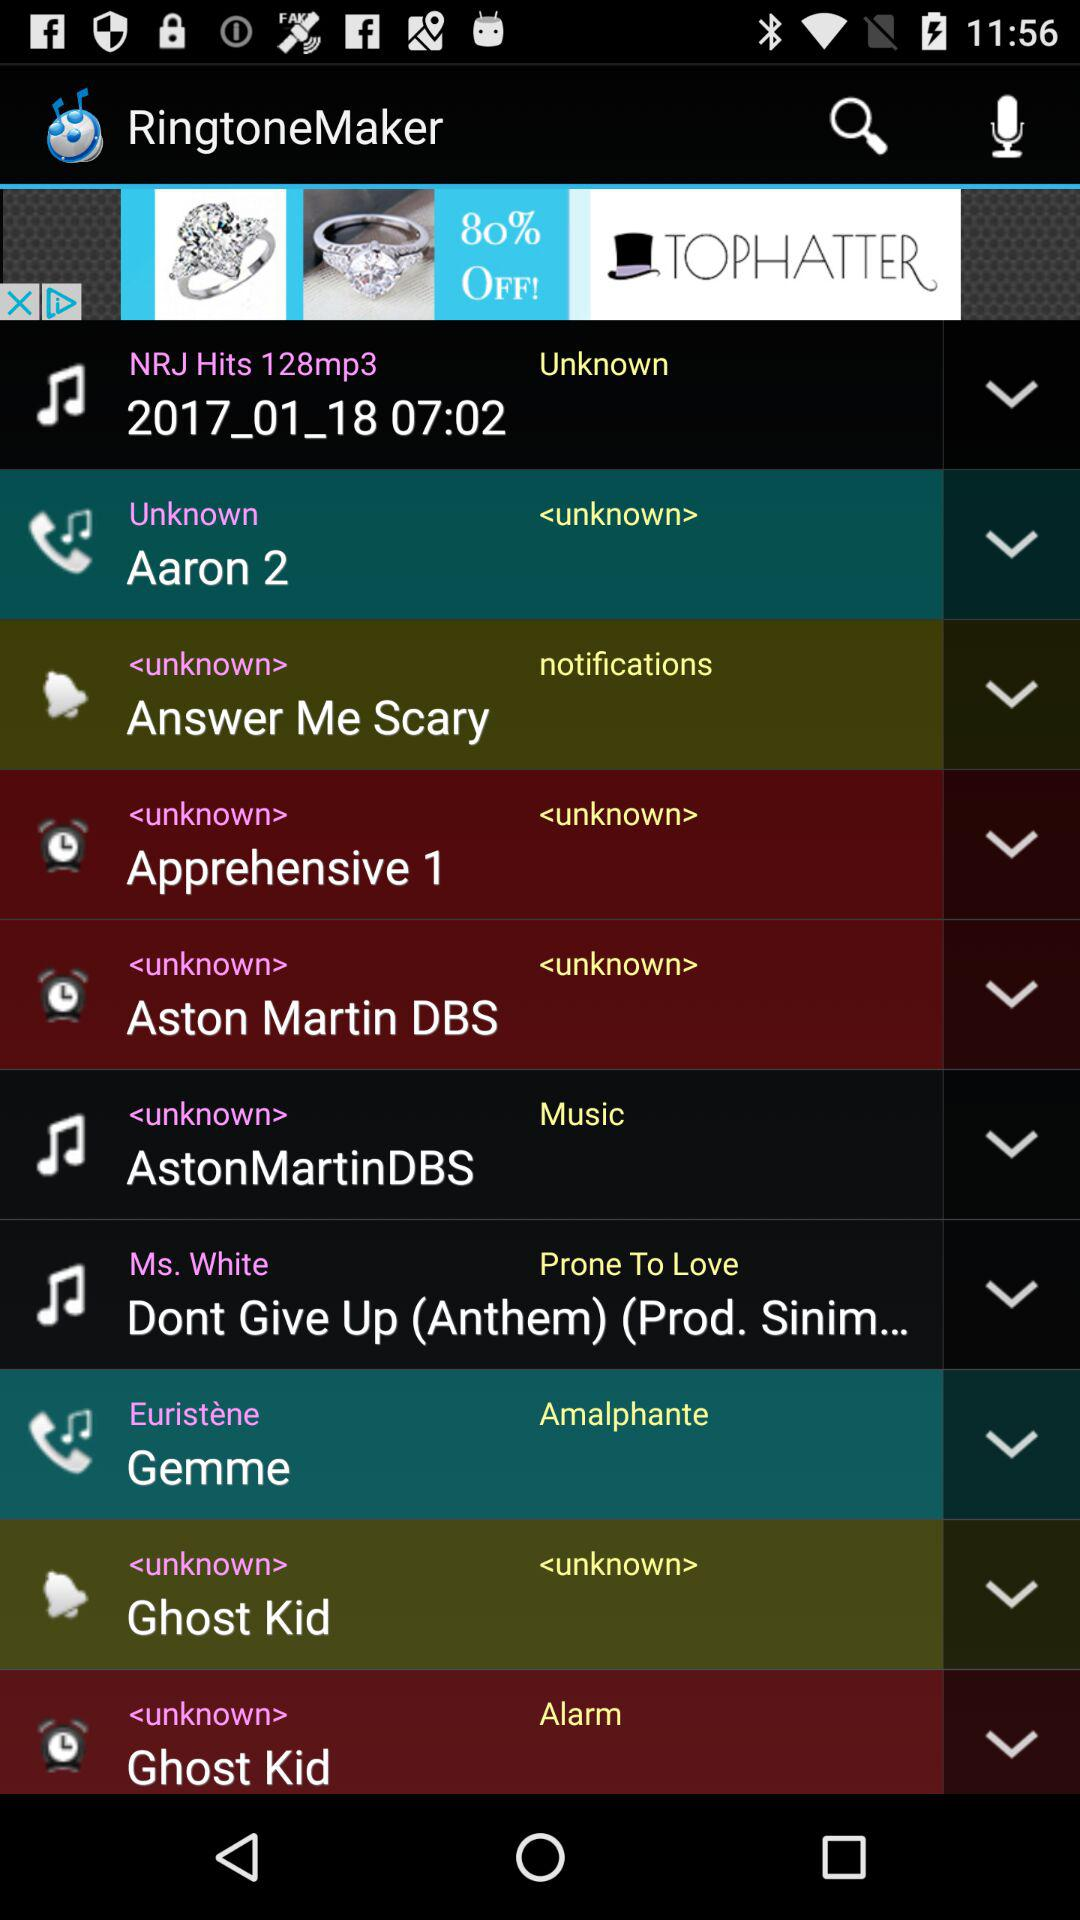What ringtone is set for the notifications? The ringtone is "Answer Me Scary". 